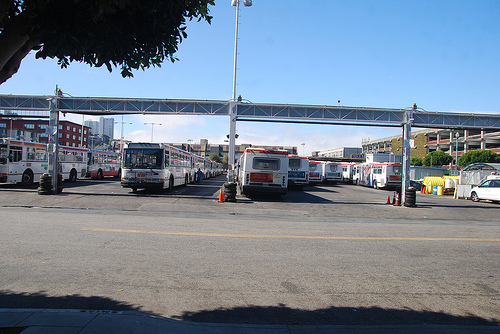What vehicle is to the right of the cone? To the right of the orange traffic cone, there's a bus parked facing our point of view, which seems to be part of a larger fleet. 